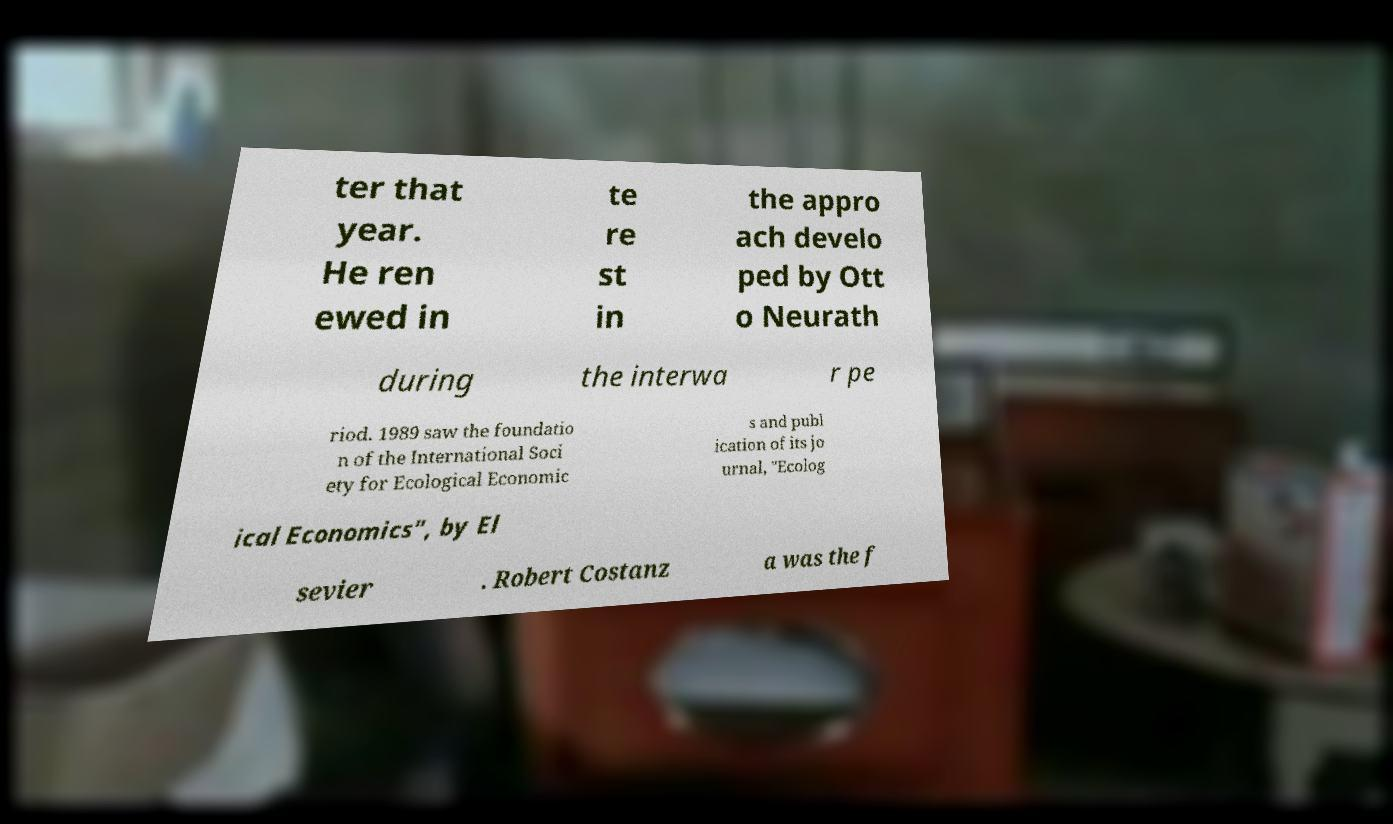Can you read and provide the text displayed in the image?This photo seems to have some interesting text. Can you extract and type it out for me? ter that year. He ren ewed in te re st in the appro ach develo ped by Ott o Neurath during the interwa r pe riod. 1989 saw the foundatio n of the International Soci ety for Ecological Economic s and publ ication of its jo urnal, "Ecolog ical Economics", by El sevier . Robert Costanz a was the f 